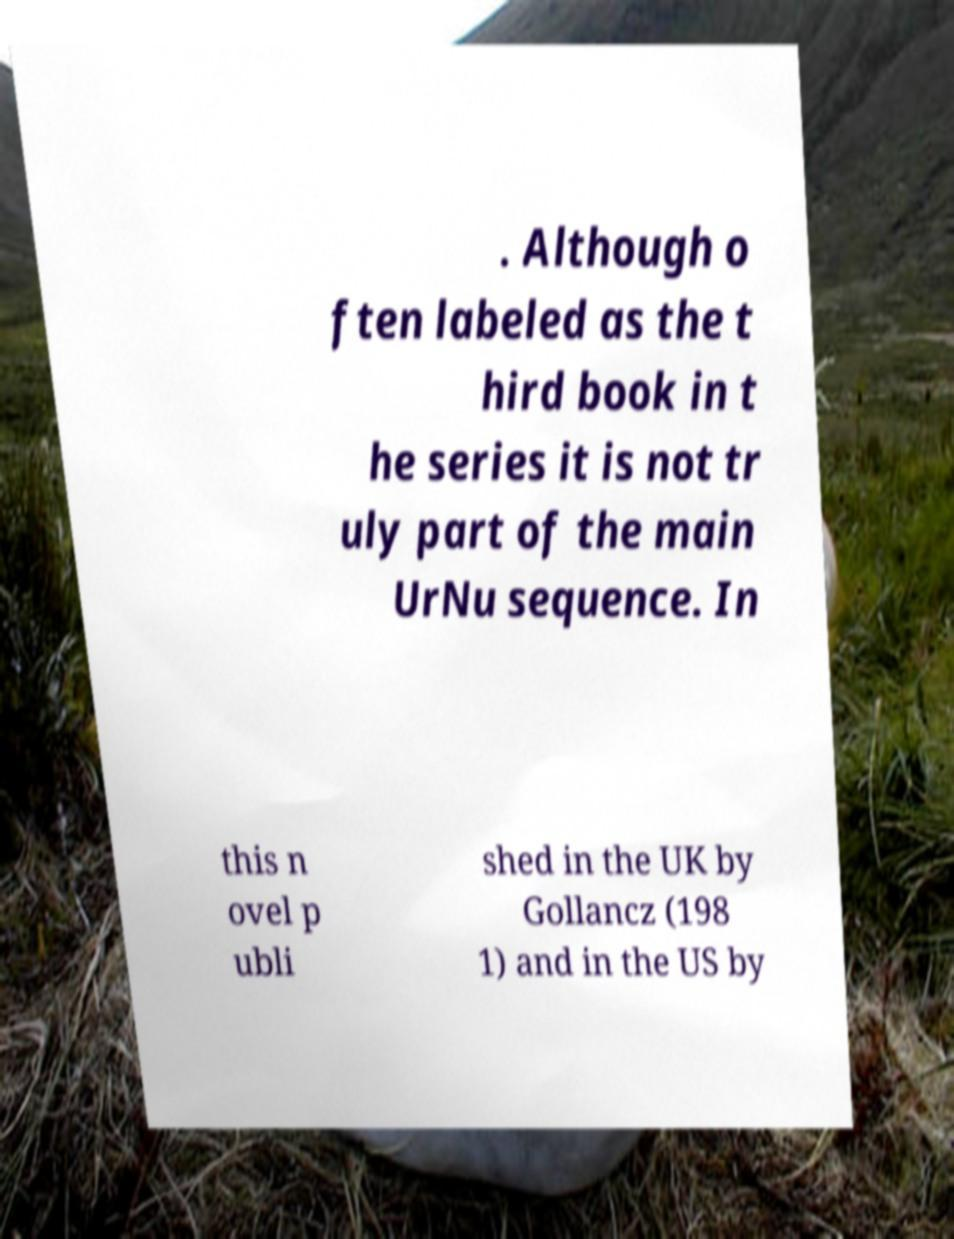Could you extract and type out the text from this image? . Although o ften labeled as the t hird book in t he series it is not tr uly part of the main UrNu sequence. In this n ovel p ubli shed in the UK by Gollancz (198 1) and in the US by 